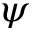<formula> <loc_0><loc_0><loc_500><loc_500>\psi</formula> 